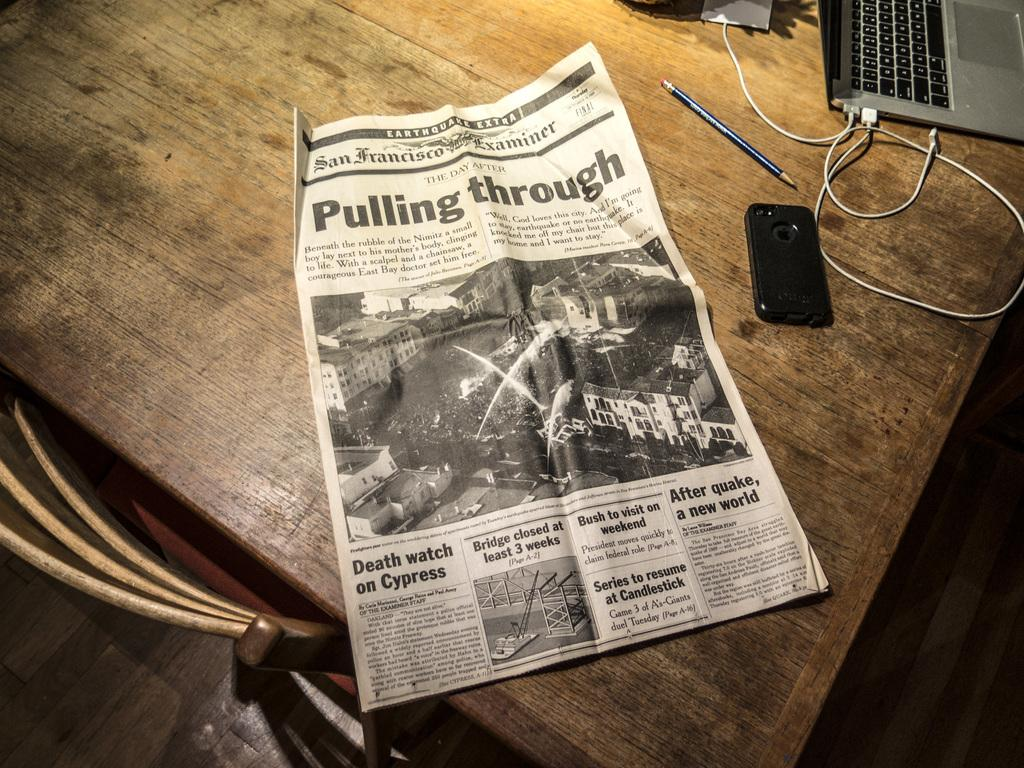<image>
Create a compact narrative representing the image presented. A newspaper with the headlines of Pulling Through is on a wooden table. 